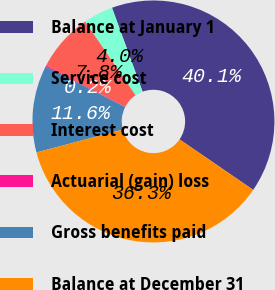Convert chart. <chart><loc_0><loc_0><loc_500><loc_500><pie_chart><fcel>Balance at January 1<fcel>Service cost<fcel>Interest cost<fcel>Actuarial (gain) loss<fcel>Gross benefits paid<fcel>Balance at December 31<nl><fcel>40.13%<fcel>3.98%<fcel>7.8%<fcel>0.16%<fcel>11.62%<fcel>36.31%<nl></chart> 